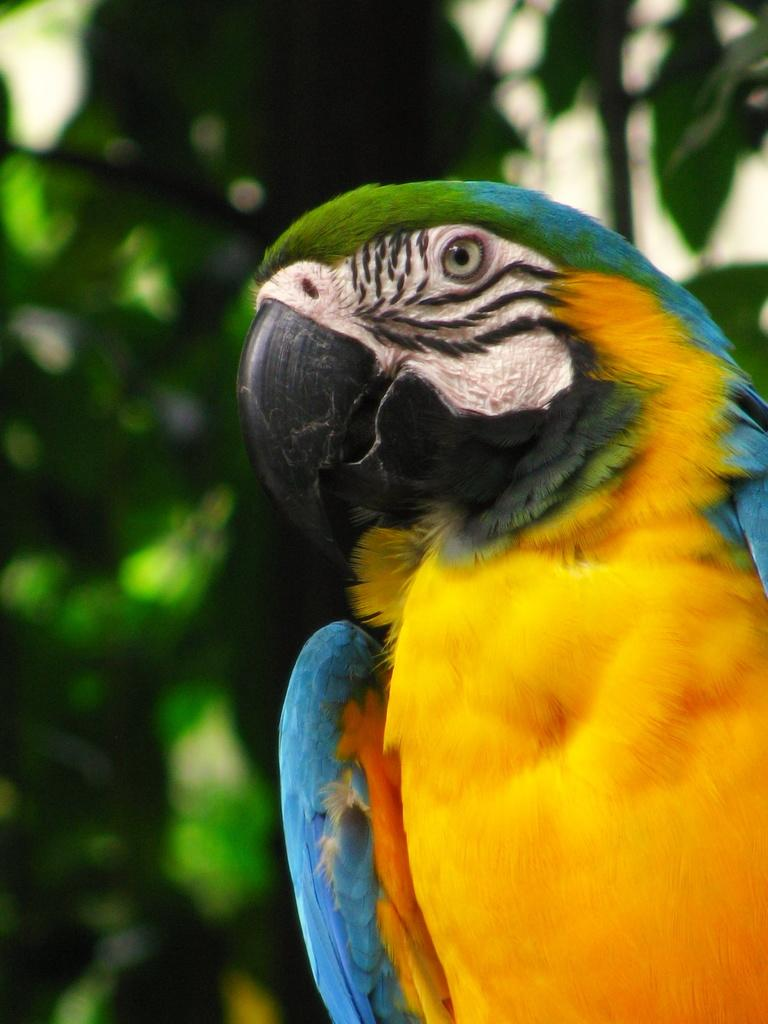What type of animal is in the image? There is a multicolored parrot in the image. What can be seen in the background of the image? There are plants visible in the background of the image. What type of umbrella is the parrot holding in the image? There is no umbrella present in the image; the parrot is not holding anything. 